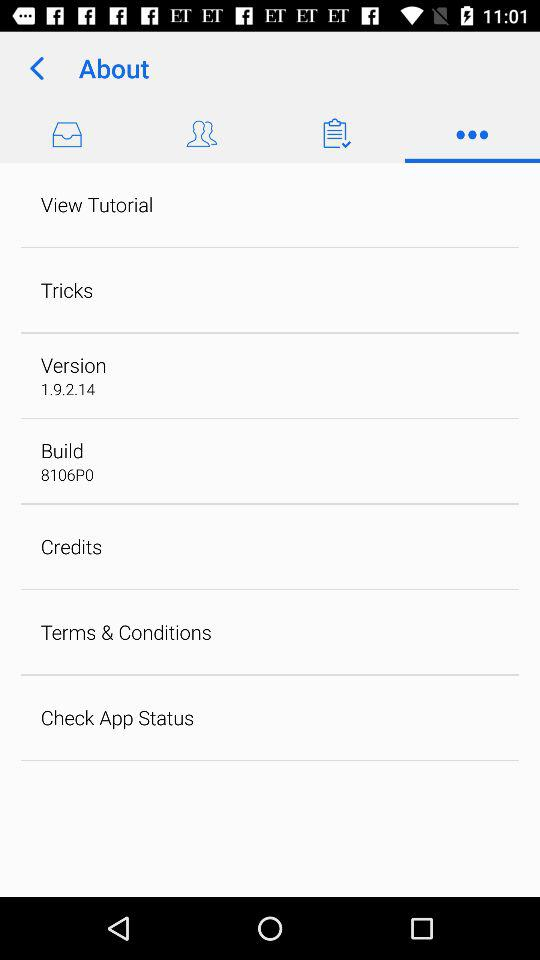What is the version of the application? The version is 1.9.2.14. 